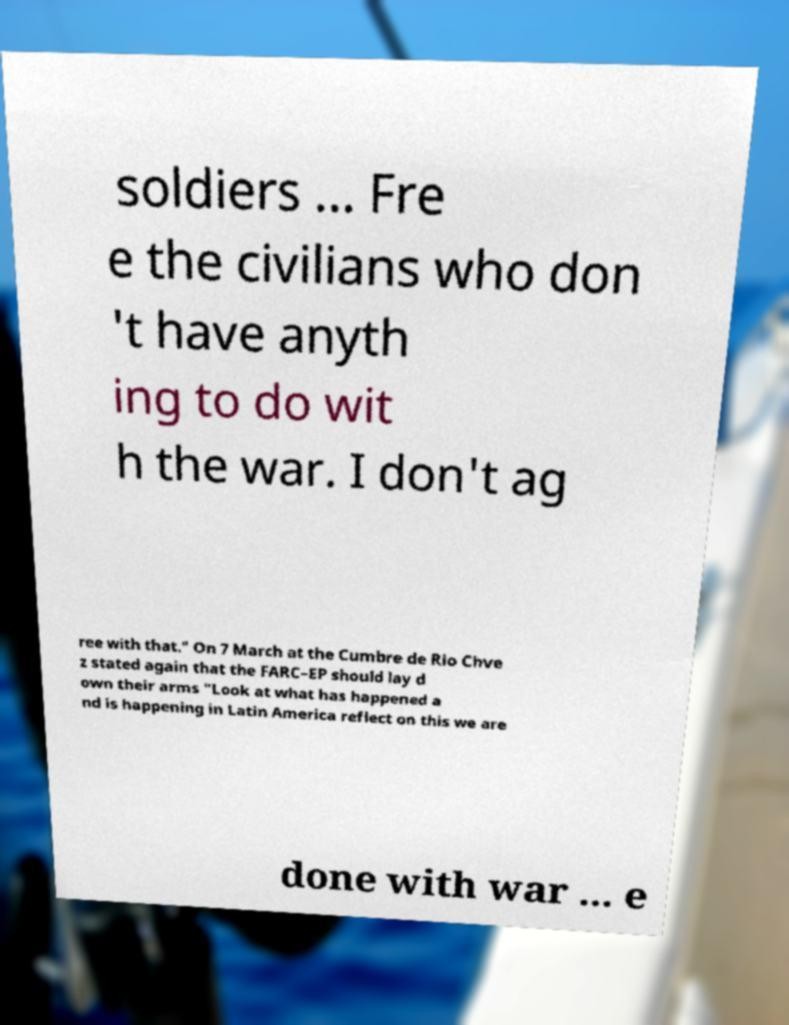Could you extract and type out the text from this image? soldiers ... Fre e the civilians who don 't have anyth ing to do wit h the war. I don't ag ree with that." On 7 March at the Cumbre de Rio Chve z stated again that the FARC–EP should lay d own their arms "Look at what has happened a nd is happening in Latin America reflect on this we are done with war ... e 